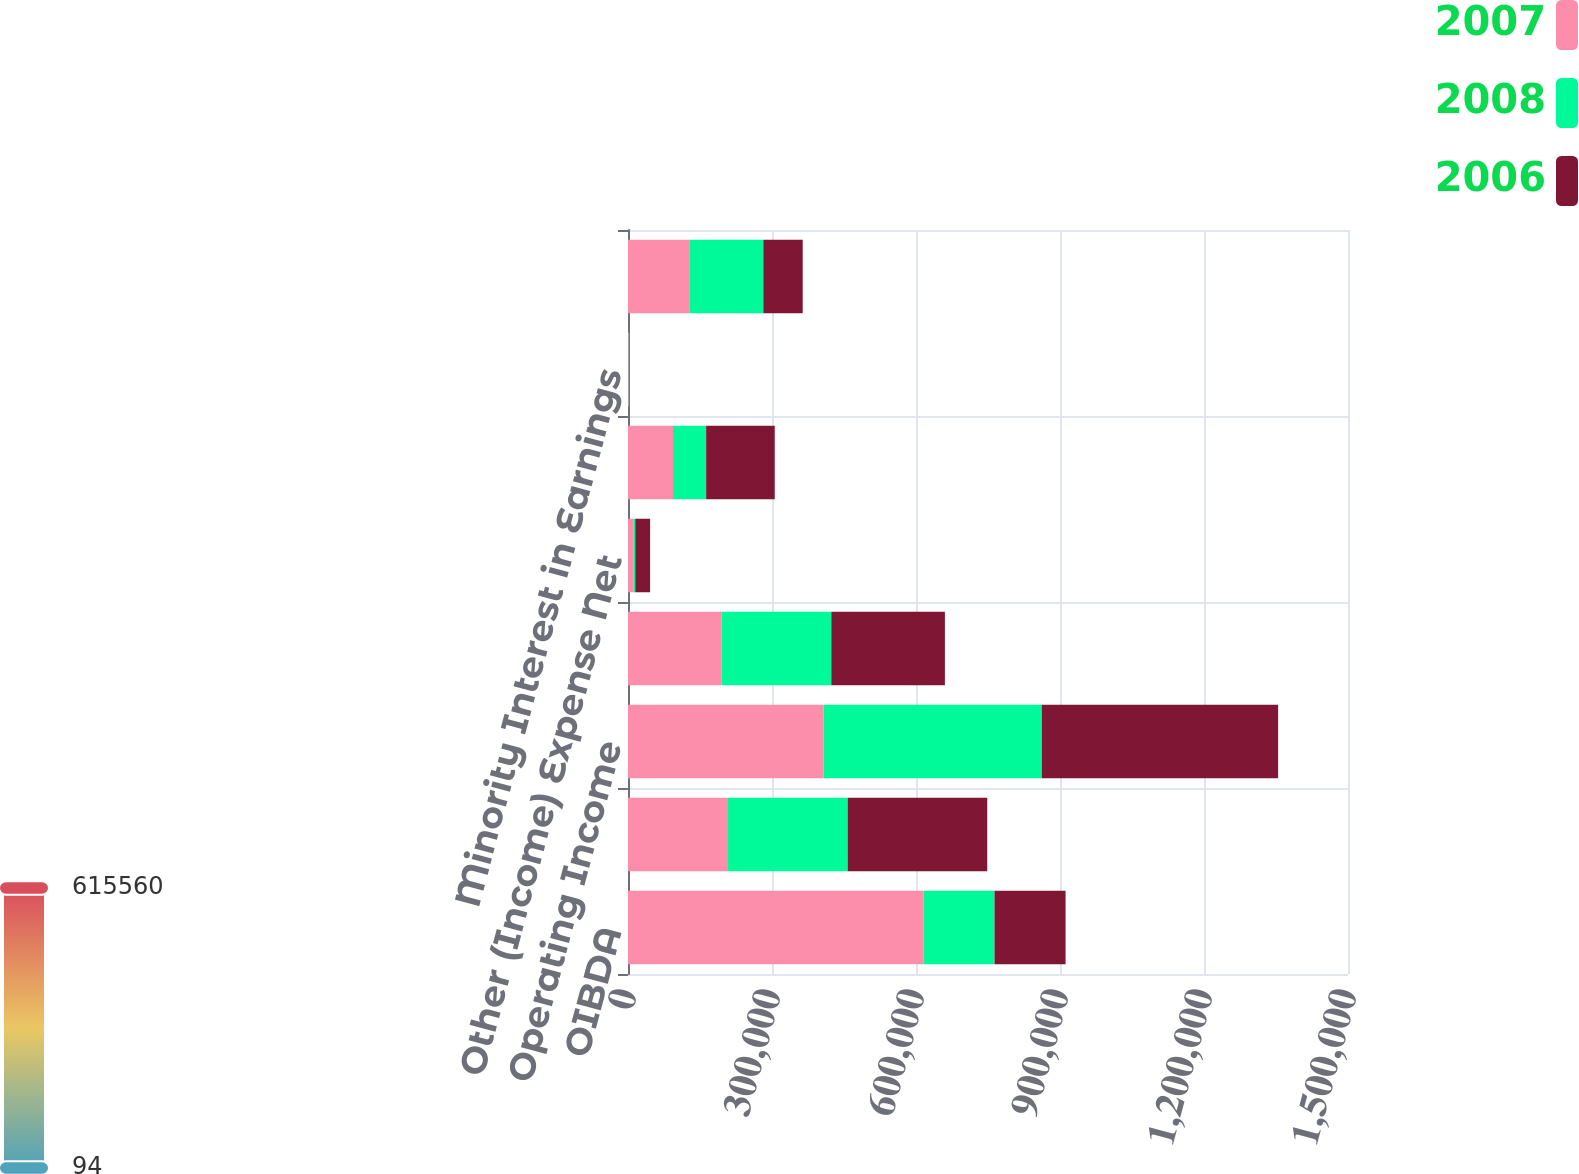Convert chart. <chart><loc_0><loc_0><loc_500><loc_500><stacked_bar_chart><ecel><fcel>OIBDA<fcel>Less Depreciation and<fcel>Operating Income<fcel>Less Interest Expense Net<fcel>Other (Income) Expense Net<fcel>Provision for Income Taxes<fcel>Minority Interest in Earnings<fcel>Net Income<nl><fcel>2007<fcel>615560<fcel>208373<fcel>407187<fcel>194958<fcel>11989<fcel>93795<fcel>1560<fcel>128863<nl><fcel>2008<fcel>148009<fcel>249294<fcel>454718<fcel>228593<fcel>3101<fcel>69010<fcel>920<fcel>153094<nl><fcel>2006<fcel>148009<fcel>290738<fcel>492530<fcel>236635<fcel>31028<fcel>142924<fcel>94<fcel>82037<nl></chart> 